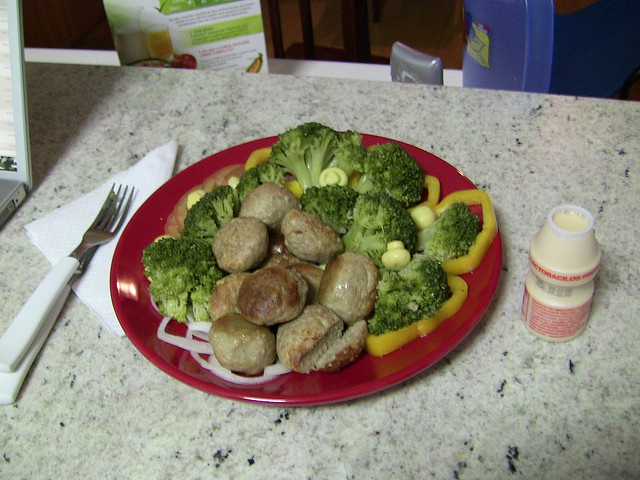Describe the objects in this image and their specific colors. I can see dining table in lightgray, darkgray, and gray tones, broccoli in lightgray, darkgreen, black, and olive tones, bottle in lightgray, beige, darkgray, brown, and tan tones, broccoli in lightgray, darkgreen, and olive tones, and laptop in lightgray, gray, darkgray, and lightblue tones in this image. 